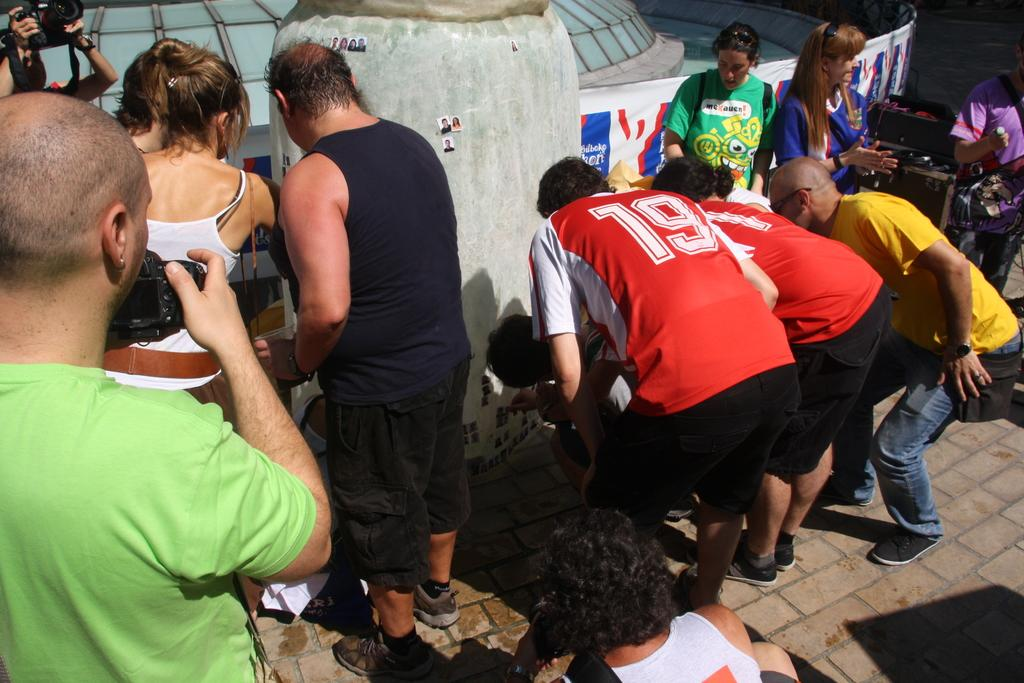How many people are in the image? There is a group of people in the image. What are two of the people doing in the image? Two persons are standing and holding cameras. What is placed on the rock in the image? There are photos on a rock in the image. What can be seen hanging or displayed in the image? There is a banner in the image. What can be seen in the background of the image? There are items visible in the background of the image. How many balls are visible in the image? There are no balls visible in the image. What type of class is being held in the image? There is no class being held in the image; it features a group of people with cameras and a banner. 